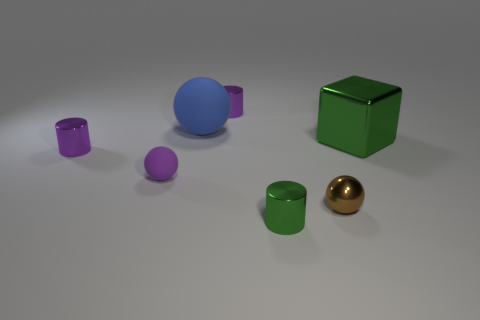Subtract all tiny balls. How many balls are left? 1 Subtract all red cubes. How many purple cylinders are left? 2 Subtract all blue spheres. How many spheres are left? 2 Subtract 1 cylinders. How many cylinders are left? 2 Add 1 tiny purple objects. How many objects exist? 8 Subtract all cubes. How many objects are left? 6 Add 3 green metallic things. How many green metallic things exist? 5 Subtract 0 cyan spheres. How many objects are left? 7 Subtract all purple cylinders. Subtract all gray balls. How many cylinders are left? 1 Subtract all red objects. Subtract all blue balls. How many objects are left? 6 